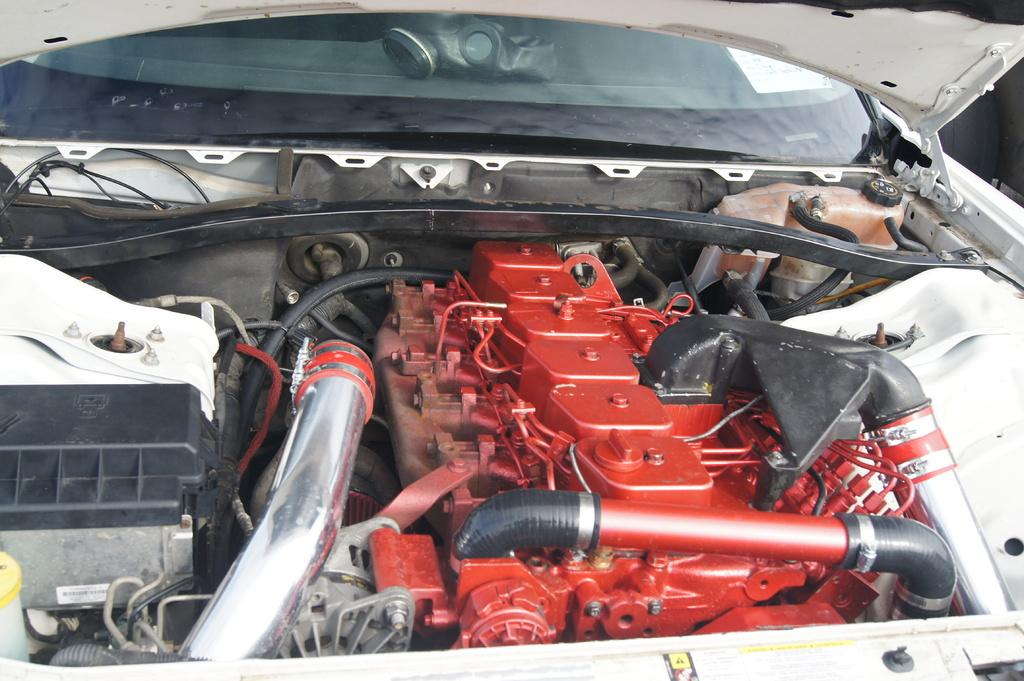What is the main subject of the image? The main subject of the image is an engine. To which type of vehicle does the engine belong? The engine belongs to a vehicle. What is the color of the engine in the image? The engine is red in color. What size of the friend in the image? There is no friend present in the image, so it is not possible to determine the size of a friend. 